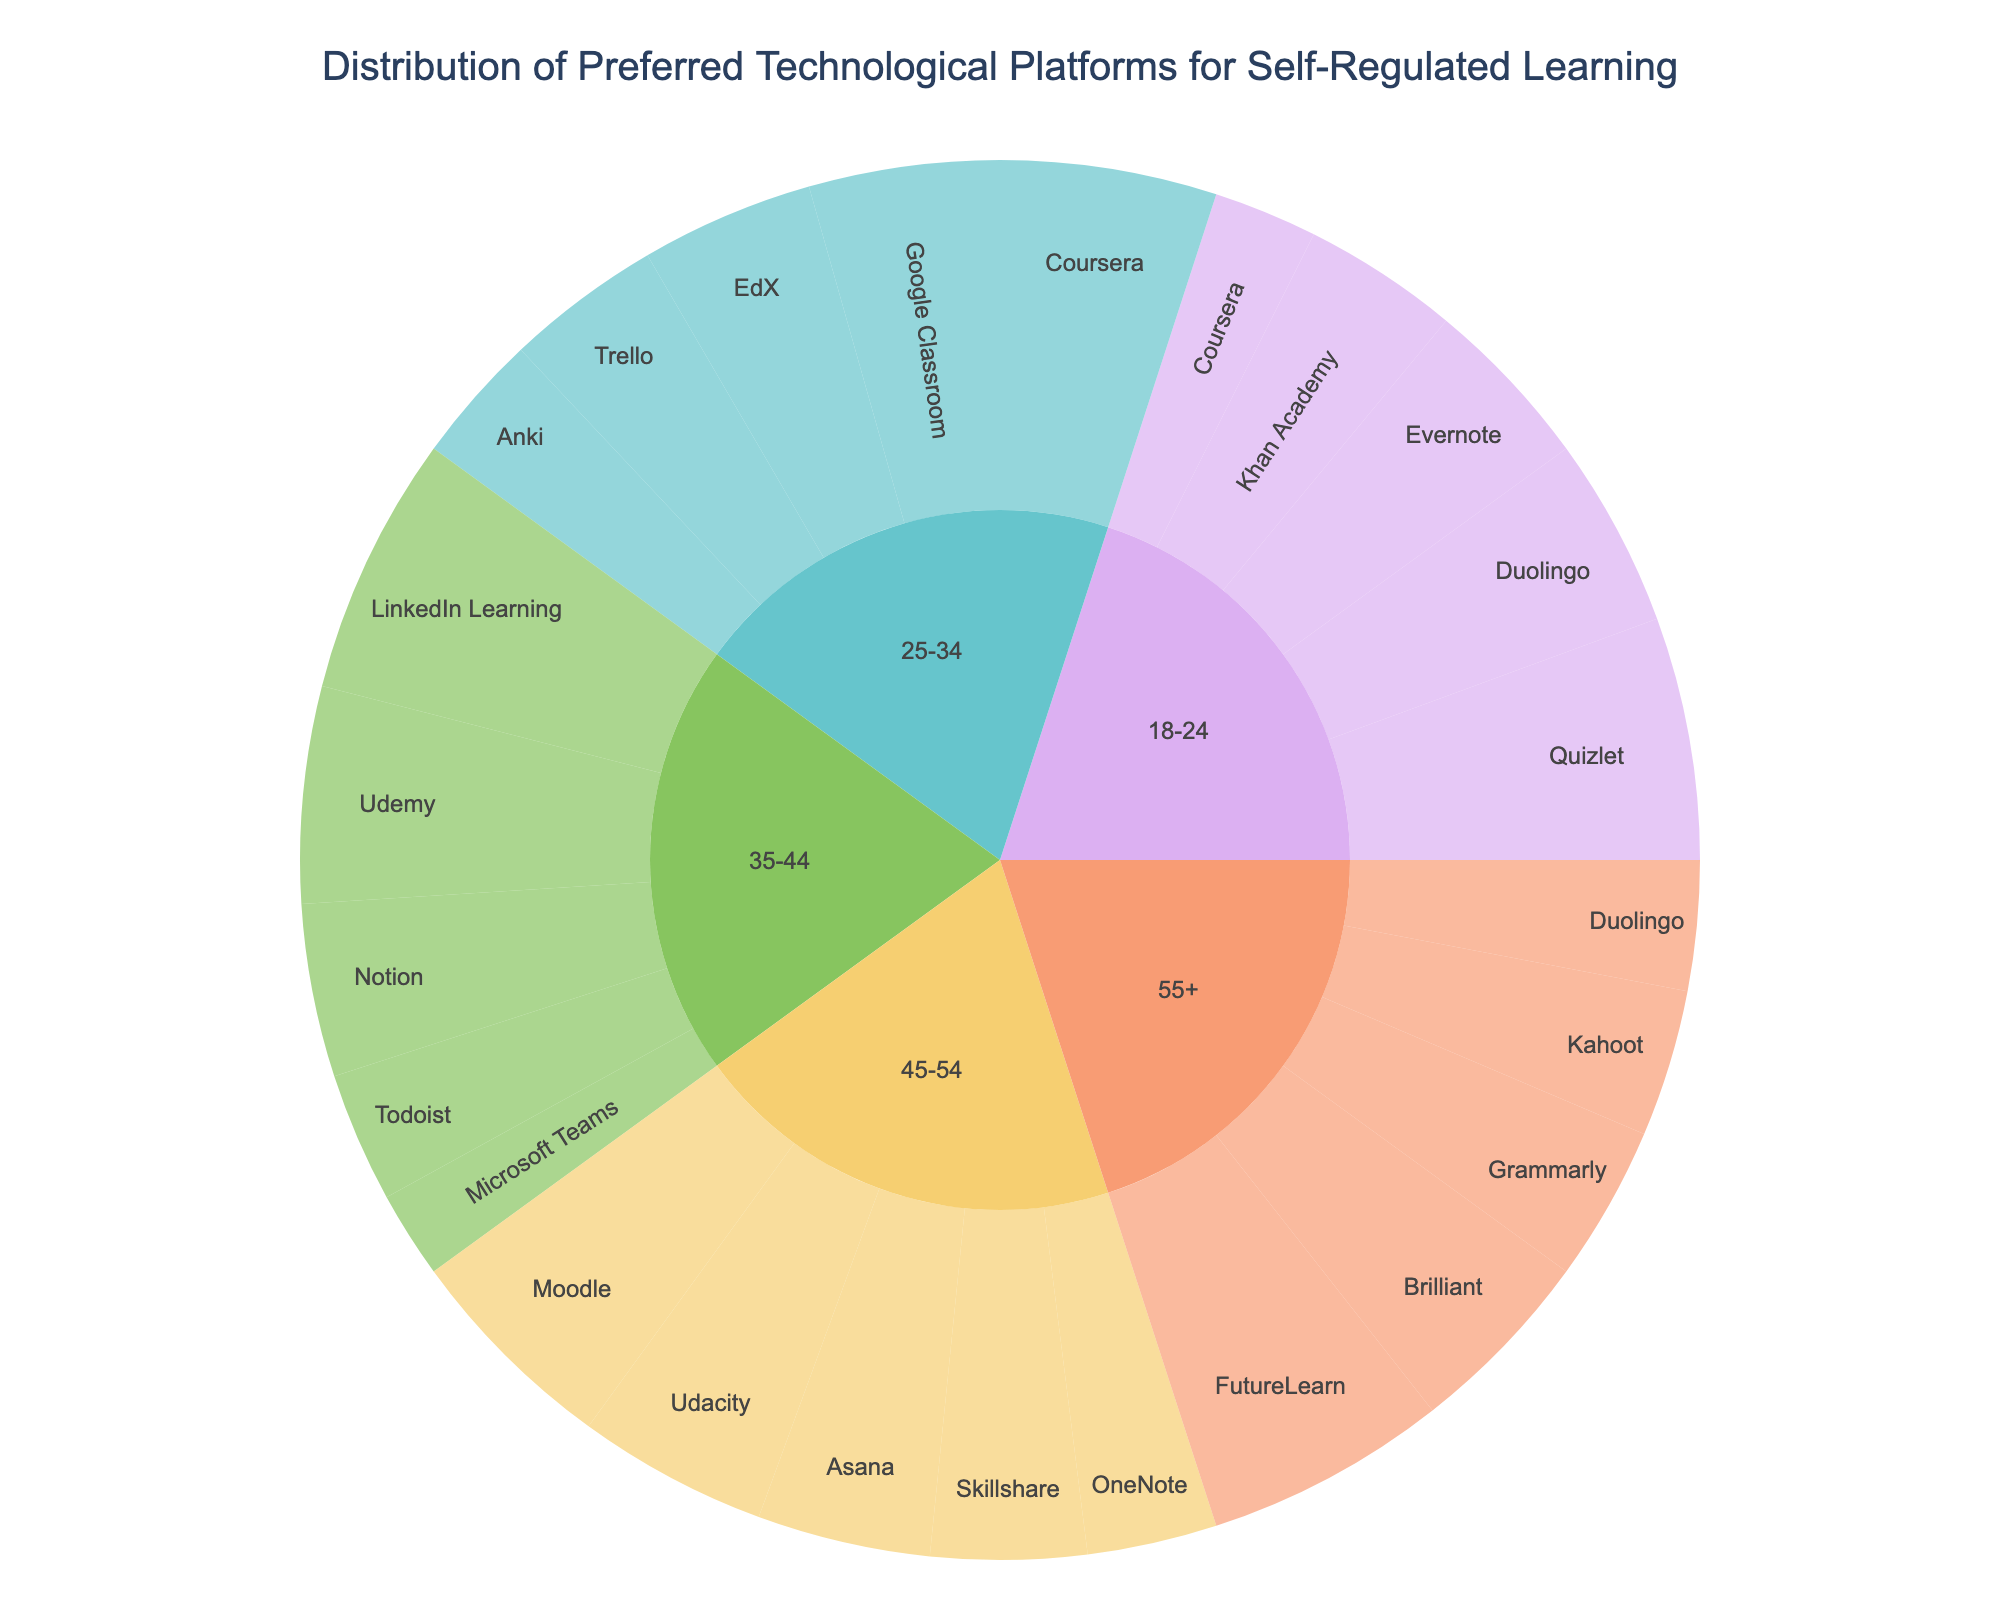What is the most preferred technological platform for self-regulated learning among the 18-24 age group? The sunburst chart shows different age groups and their preferred platforms. For the 18-24 age group, Quizlet has the highest percentage.
Answer: Quizlet Which age group prefers Coursera the most? Look at the segments for Coursera across all age groups. The 25-34 age group has the largest segment for Coursera.
Answer: 25-34 Is Duolingo more popular among the 18-24 age group or the 55+ age group? Compare the Duolingo segments for both age groups. The 18-24 age group has a 22% segment for Duolingo, while the 55+ age group has a 15% segment.
Answer: 18-24 What's the total percentage for learning platforms preferred by the 35-44 age group? Add the percentages for LinkedIn Learning, Udemy, Notion, Todoist, and Microsoft Teams: 30 + 25 + 20 + 15 + 10 = 100%.
Answer: 100% Which platform has the highest percentage among all age groups? Observe the chart to find the largest segment among all age groups. Quizlet in the 18-24 age group has the largest segment at 28%.
Answer: Quizlet What is the difference in preference percentage between Khan Academy (18-24) and Notion (35-44)? Subtract the percentage of Notion (20%) from Khan Academy (18%): 18 - 20 = -2.
Answer: -2 Is the preference for Google Classroom greater than Trello for the 25-34 age group? Compare the percentages for Google Classroom (22%) and Trello (18%) in the 25-34 age group.
Answer: Yes What is the average percentage for platforms preferred by the 45-54 age group? Sum the percentages for Udacity, Skillshare, Moodle, Asana, and OneNote: 22 + 18 + 25 + 20 + 15 = 100. Divide by 5: 100 / 5 = 20.
Answer: 20 Among all age groups, which platform has the highest preference and what is the percentage? Identify the largest segment in the entire chart, which is Quizlet for 18-24 with 28%.
Answer: Quizlet, 28 Which two platforms are equally preferred by the 55+ age group and what is their percentage? Find segments with matching percentages in the 55+ group. Duolingo and Kahoot both have a 15% preference.
Answer: Duolingo and Kahoot, 15 